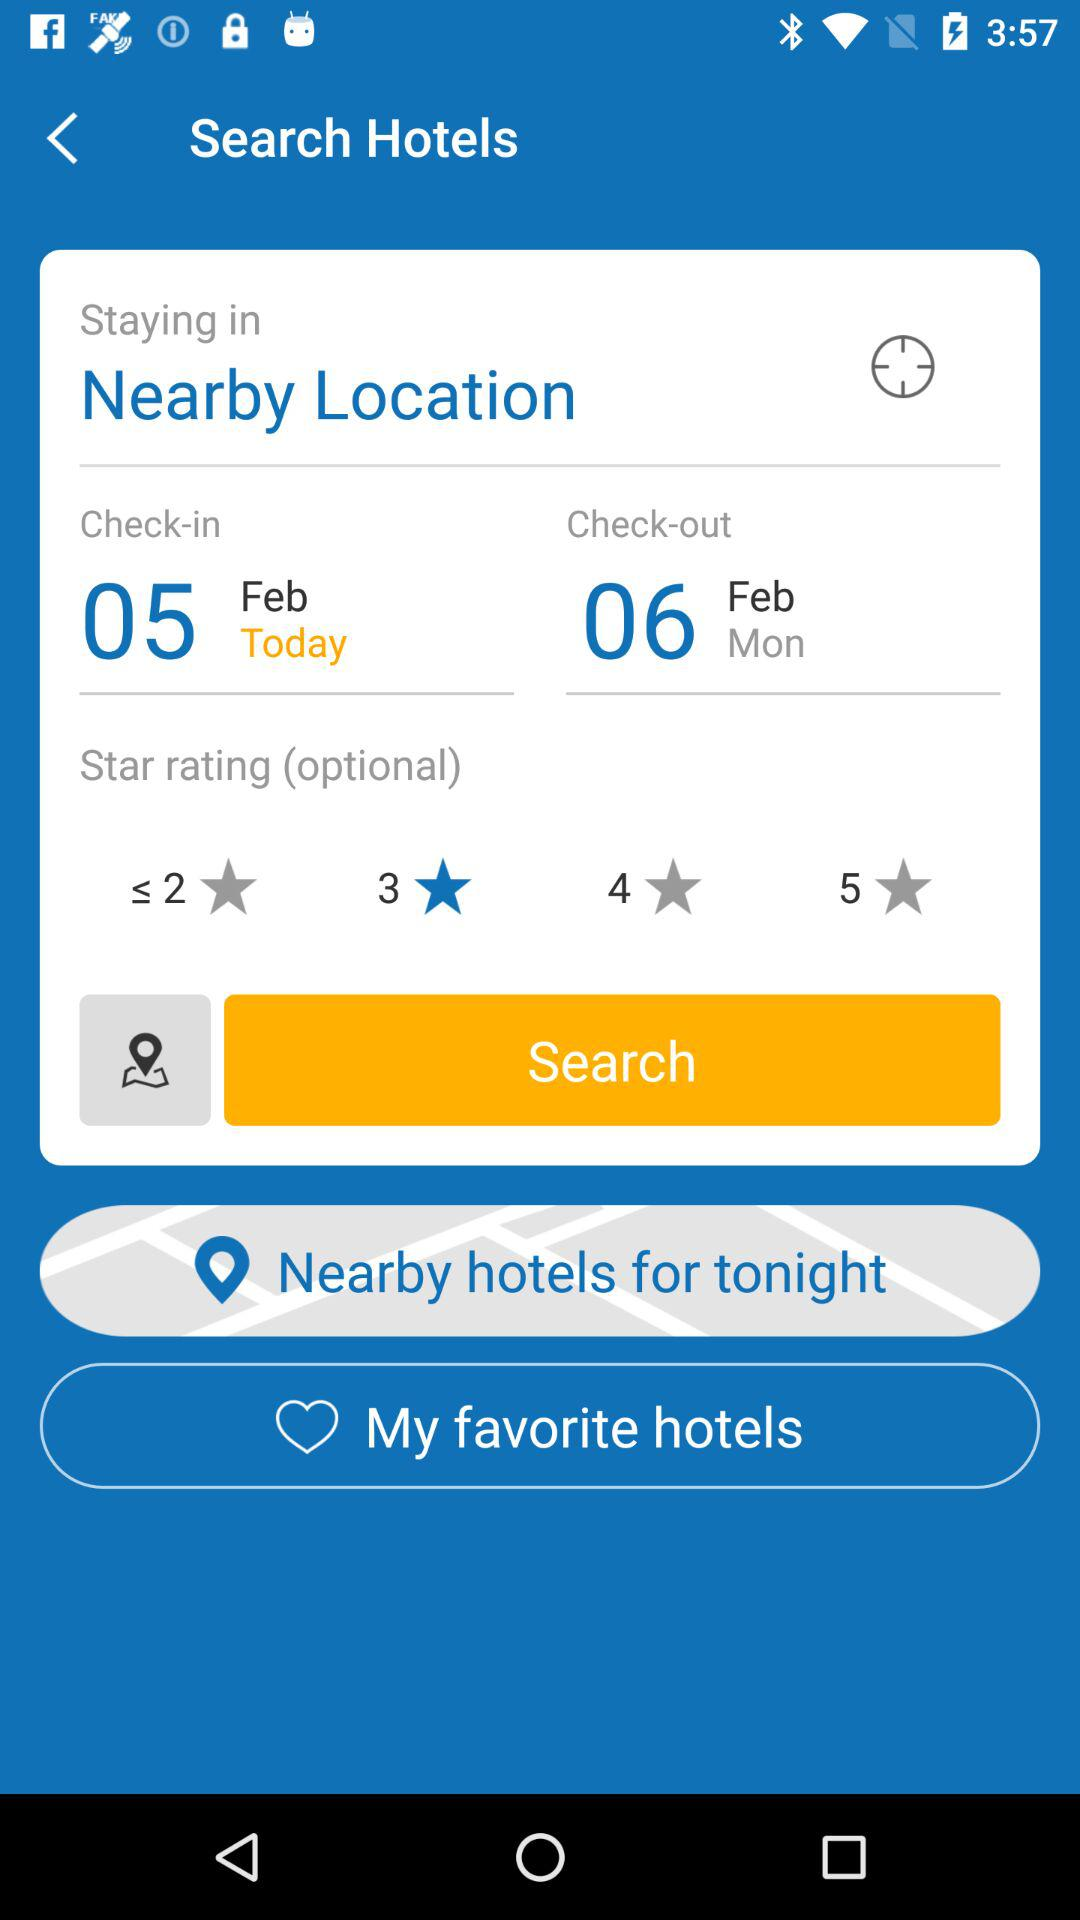What is the check-in date? The check-in date is February 5. 